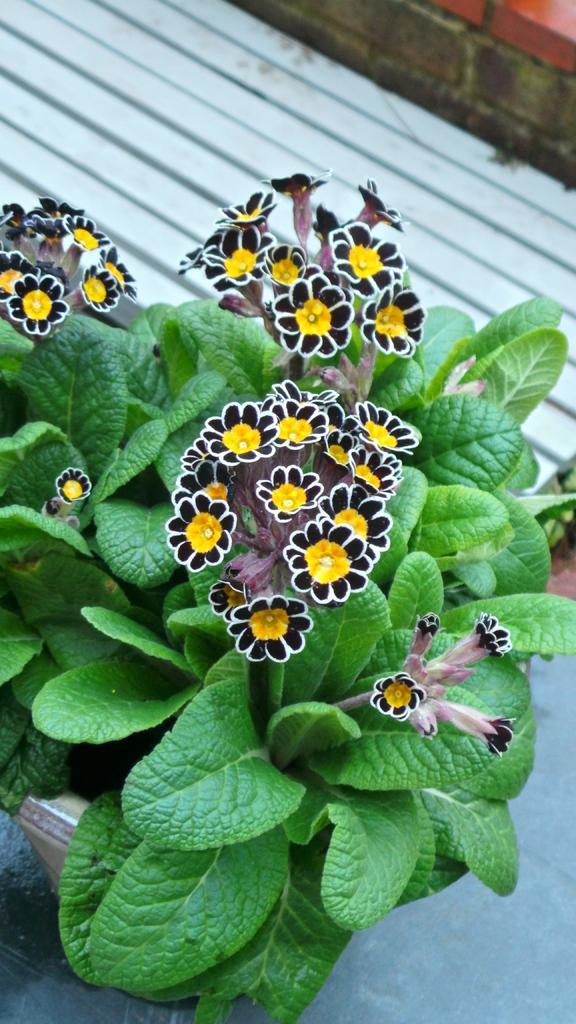What type of plant is visible in the image? There is a plant in the image. What additional features can be seen on the plant? There are flowers in the image. What can be seen in the background of the image? There is a brick wall in the background of the image. What riddle is written on the notebook in the image? There is no notebook present in the image, so no riddle can be observed. 